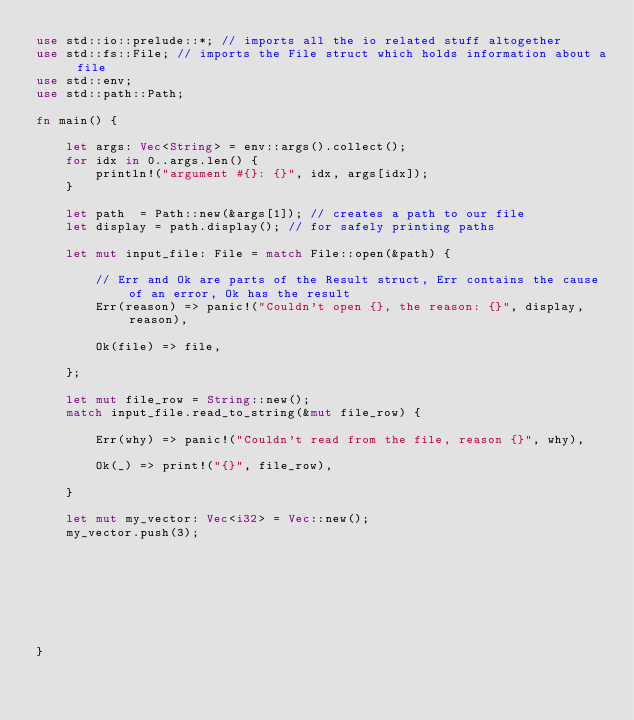<code> <loc_0><loc_0><loc_500><loc_500><_Rust_>use std::io::prelude::*; // imports all the io related stuff altogether
use std::fs::File; // imports the File struct which holds information about a file
use std::env;
use std::path::Path;

fn main() {

    let args: Vec<String> = env::args().collect(); 
    for idx in 0..args.len() {
        println!("argument #{}: {}", idx, args[idx]);
    }

    let path  = Path::new(&args[1]); // creates a path to our file
    let display = path.display(); // for safely printing paths

    let mut input_file: File = match File::open(&path) {
 
        // Err and Ok are parts of the Result struct, Err contains the cause of an error, Ok has the result
        Err(reason) => panic!("Couldn't open {}, the reason: {}", display, reason),

        Ok(file) => file,

    };

    let mut file_row = String::new();
    match input_file.read_to_string(&mut file_row) {

        Err(why) => panic!("Couldn't read from the file, reason {}", why),

        Ok(_) => print!("{}", file_row),

    }

    let mut my_vector: Vec<i32> = Vec::new();
    my_vector.push(3);








}
</code> 